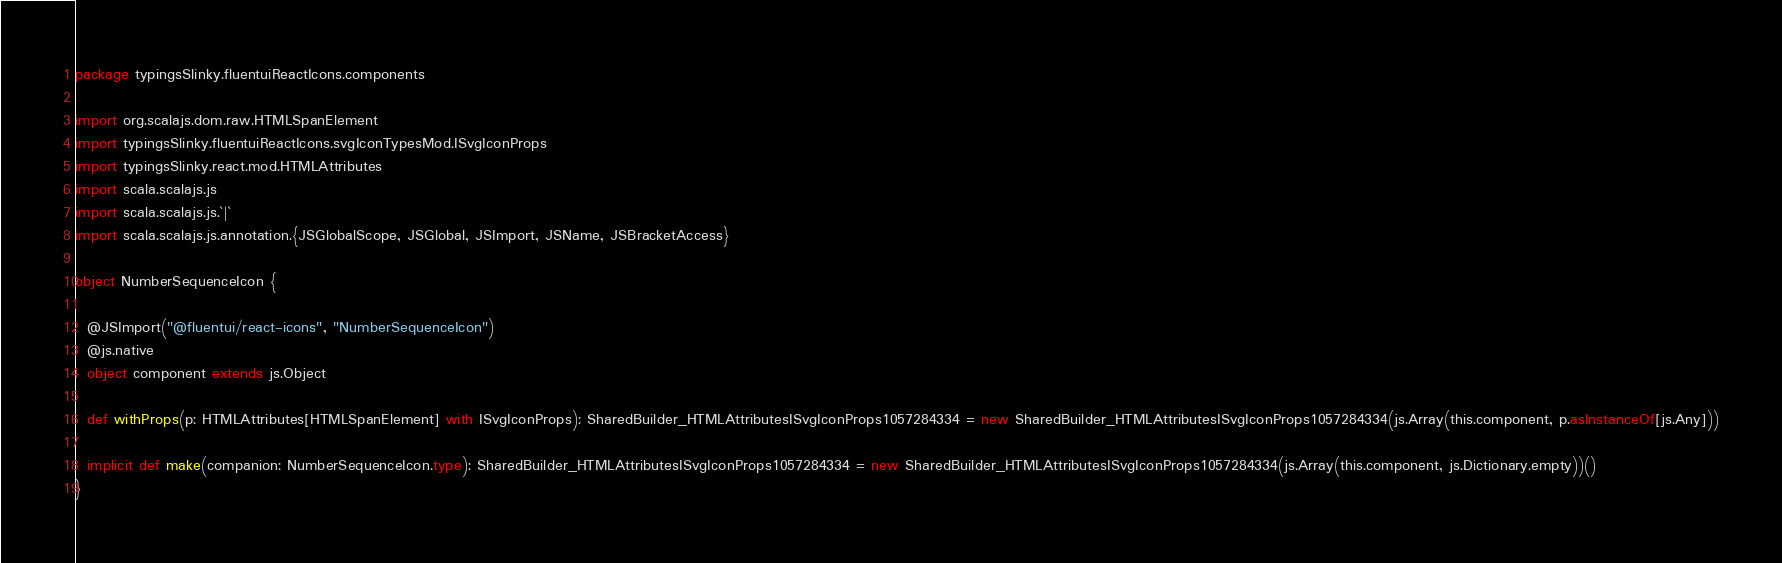Convert code to text. <code><loc_0><loc_0><loc_500><loc_500><_Scala_>package typingsSlinky.fluentuiReactIcons.components

import org.scalajs.dom.raw.HTMLSpanElement
import typingsSlinky.fluentuiReactIcons.svgIconTypesMod.ISvgIconProps
import typingsSlinky.react.mod.HTMLAttributes
import scala.scalajs.js
import scala.scalajs.js.`|`
import scala.scalajs.js.annotation.{JSGlobalScope, JSGlobal, JSImport, JSName, JSBracketAccess}

object NumberSequenceIcon {
  
  @JSImport("@fluentui/react-icons", "NumberSequenceIcon")
  @js.native
  object component extends js.Object
  
  def withProps(p: HTMLAttributes[HTMLSpanElement] with ISvgIconProps): SharedBuilder_HTMLAttributesISvgIconProps1057284334 = new SharedBuilder_HTMLAttributesISvgIconProps1057284334(js.Array(this.component, p.asInstanceOf[js.Any]))
  
  implicit def make(companion: NumberSequenceIcon.type): SharedBuilder_HTMLAttributesISvgIconProps1057284334 = new SharedBuilder_HTMLAttributesISvgIconProps1057284334(js.Array(this.component, js.Dictionary.empty))()
}
</code> 